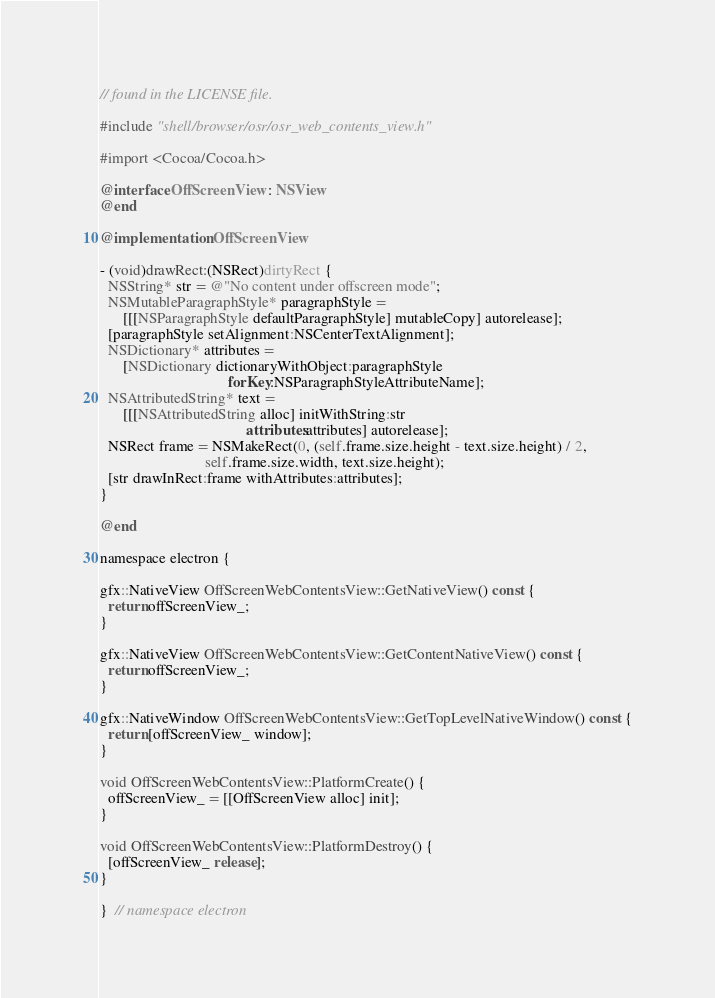<code> <loc_0><loc_0><loc_500><loc_500><_ObjectiveC_>// found in the LICENSE file.

#include "shell/browser/osr/osr_web_contents_view.h"

#import <Cocoa/Cocoa.h>

@interface OffScreenView : NSView
@end

@implementation OffScreenView

- (void)drawRect:(NSRect)dirtyRect {
  NSString* str = @"No content under offscreen mode";
  NSMutableParagraphStyle* paragraphStyle =
      [[[NSParagraphStyle defaultParagraphStyle] mutableCopy] autorelease];
  [paragraphStyle setAlignment:NSCenterTextAlignment];
  NSDictionary* attributes =
      [NSDictionary dictionaryWithObject:paragraphStyle
                                  forKey:NSParagraphStyleAttributeName];
  NSAttributedString* text =
      [[[NSAttributedString alloc] initWithString:str
                                       attributes:attributes] autorelease];
  NSRect frame = NSMakeRect(0, (self.frame.size.height - text.size.height) / 2,
                            self.frame.size.width, text.size.height);
  [str drawInRect:frame withAttributes:attributes];
}

@end

namespace electron {

gfx::NativeView OffScreenWebContentsView::GetNativeView() const {
  return offScreenView_;
}

gfx::NativeView OffScreenWebContentsView::GetContentNativeView() const {
  return offScreenView_;
}

gfx::NativeWindow OffScreenWebContentsView::GetTopLevelNativeWindow() const {
  return [offScreenView_ window];
}

void OffScreenWebContentsView::PlatformCreate() {
  offScreenView_ = [[OffScreenView alloc] init];
}

void OffScreenWebContentsView::PlatformDestroy() {
  [offScreenView_ release];
}

}  // namespace electron
</code> 